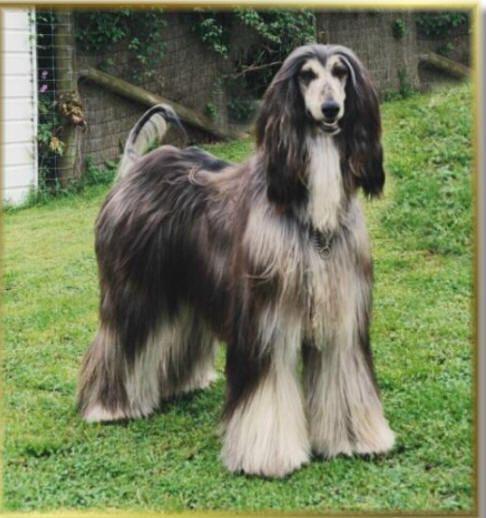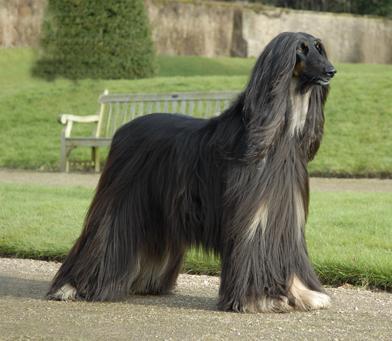The first image is the image on the left, the second image is the image on the right. Examine the images to the left and right. Is the description "There is a person standing with the dog in the image on the right." accurate? Answer yes or no. No. The first image is the image on the left, the second image is the image on the right. For the images displayed, is the sentence "A person in blue jeans is standing behind a dark afghan hound facing leftward." factually correct? Answer yes or no. No. 